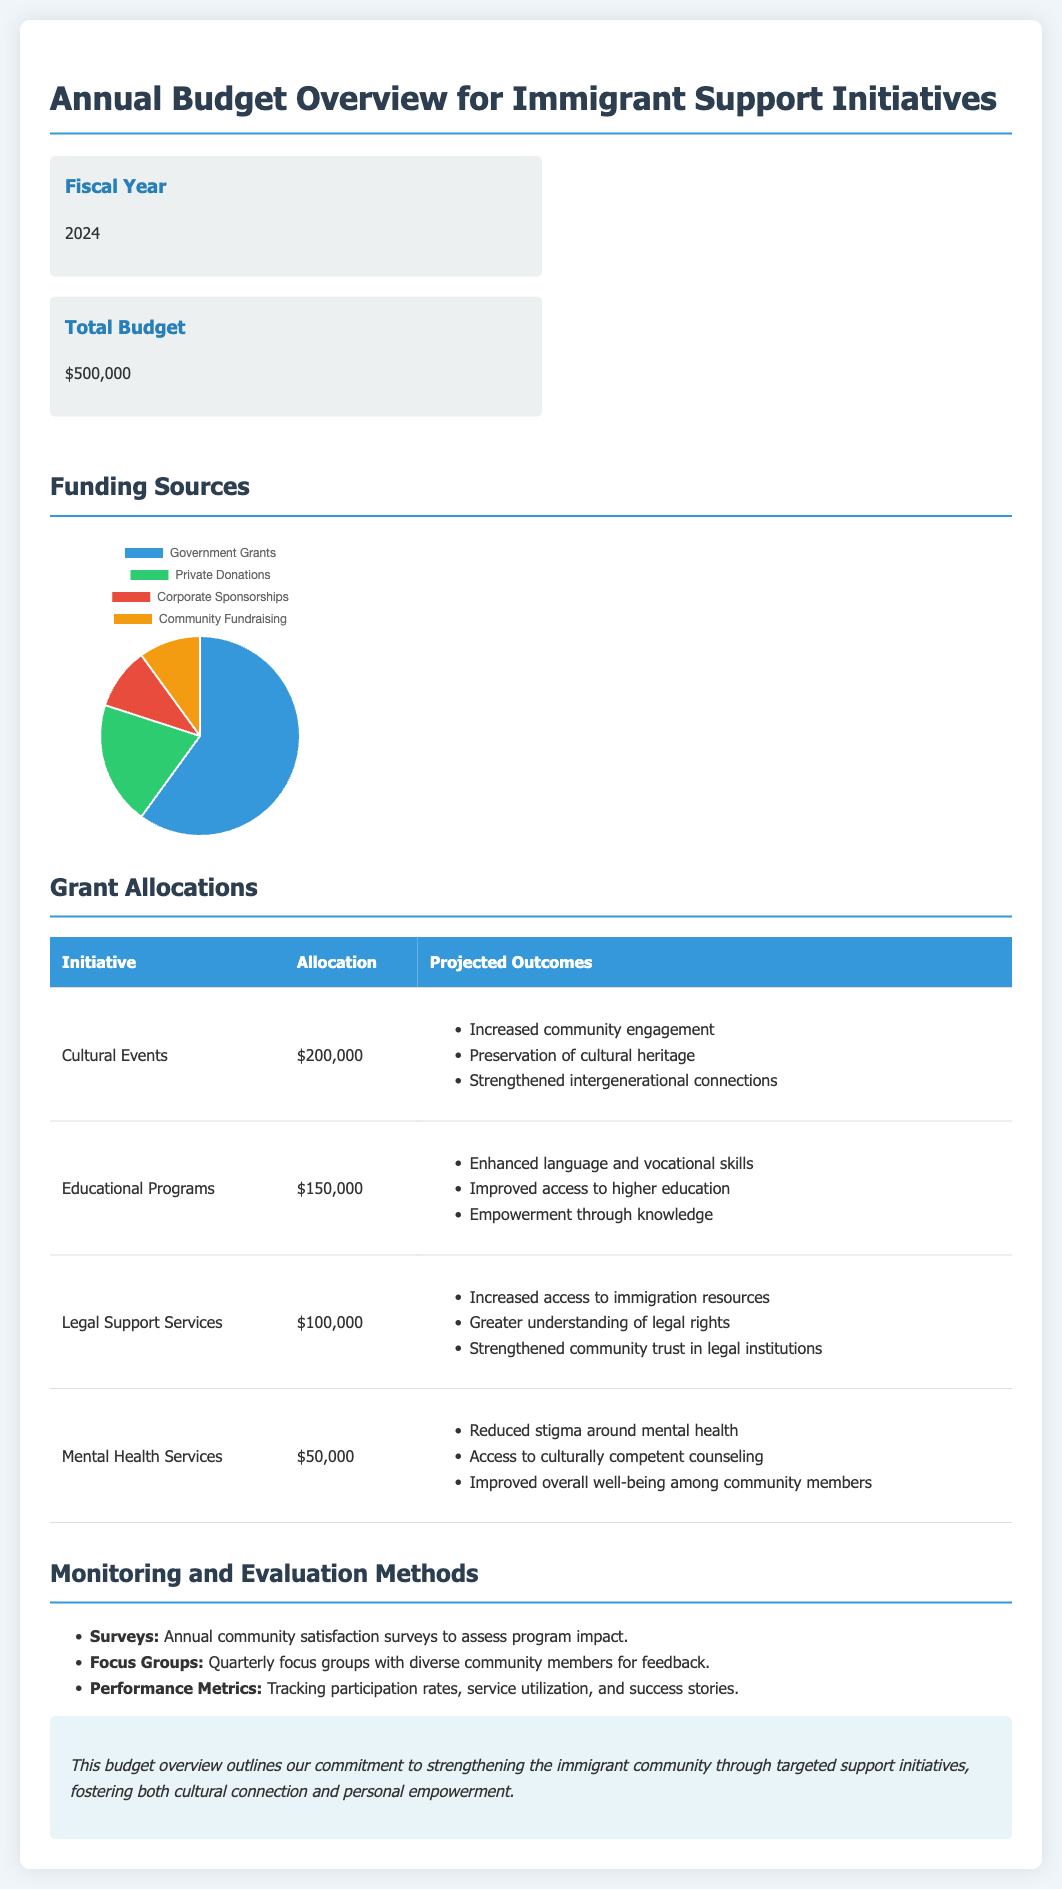What is the total budget? The total budget is presented as a specific amount in the document.
Answer: $500,000 What is the allocation for Cultural Events? This allocation amount is specified in the grant allocations table.
Answer: $200,000 How much funding is allocated to Mental Health Services? This is directly listed in the table under Grant Allocations.
Answer: $50,000 What is one projected outcome of Educational Programs? This information can be found in the outcomes listed in the Grant Allocations section.
Answer: Enhanced language and vocational skills Which funding source has the highest amount? The amounts for each funding source given in the pie chart indicate this information.
Answer: Government Grants What year is the fiscal year noted in the document? The fiscal year is explicitly mentioned in the budget overview section.
Answer: 2024 How many total initiatives are listed in Grant Allocations? This can be calculated based on the number of rows in the Grant Allocations table.
Answer: 4 What monitoring method involves annual surveys? This method is described in the Monitoring and Evaluation Methods section.
Answer: Surveys What is the background color for Corporate Sponsorships in the chart? This information can be visually retrieved from the pie chart color scheme provided in the document.
Answer: Red 